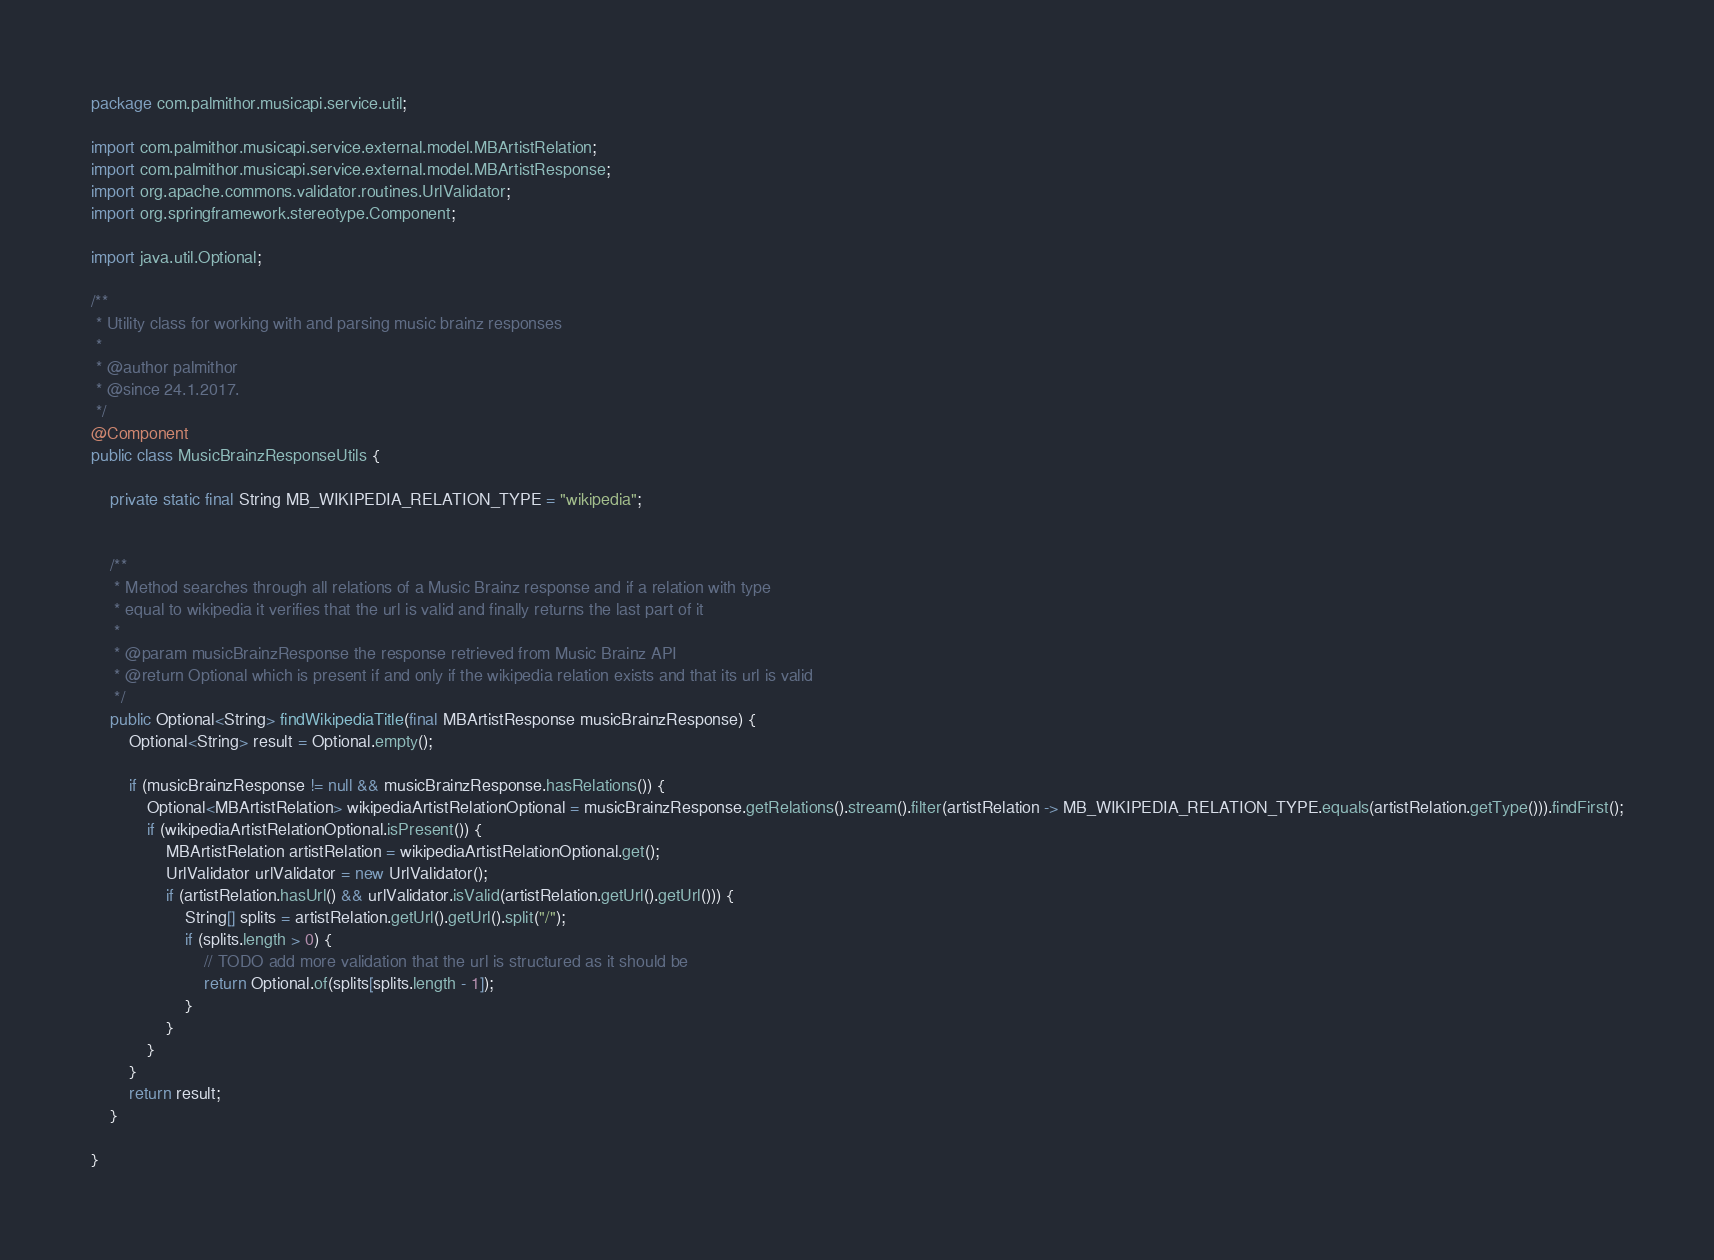<code> <loc_0><loc_0><loc_500><loc_500><_Java_>package com.palmithor.musicapi.service.util;

import com.palmithor.musicapi.service.external.model.MBArtistRelation;
import com.palmithor.musicapi.service.external.model.MBArtistResponse;
import org.apache.commons.validator.routines.UrlValidator;
import org.springframework.stereotype.Component;

import java.util.Optional;

/**
 * Utility class for working with and parsing music brainz responses
 *
 * @author palmithor
 * @since 24.1.2017.
 */
@Component
public class MusicBrainzResponseUtils {

    private static final String MB_WIKIPEDIA_RELATION_TYPE = "wikipedia";


    /**
     * Method searches through all relations of a Music Brainz response and if a relation with type
     * equal to wikipedia it verifies that the url is valid and finally returns the last part of it
     *
     * @param musicBrainzResponse the response retrieved from Music Brainz API
     * @return Optional which is present if and only if the wikipedia relation exists and that its url is valid
     */
    public Optional<String> findWikipediaTitle(final MBArtistResponse musicBrainzResponse) {
        Optional<String> result = Optional.empty();

        if (musicBrainzResponse != null && musicBrainzResponse.hasRelations()) {
            Optional<MBArtistRelation> wikipediaArtistRelationOptional = musicBrainzResponse.getRelations().stream().filter(artistRelation -> MB_WIKIPEDIA_RELATION_TYPE.equals(artistRelation.getType())).findFirst();
            if (wikipediaArtistRelationOptional.isPresent()) {
                MBArtistRelation artistRelation = wikipediaArtistRelationOptional.get();
                UrlValidator urlValidator = new UrlValidator();
                if (artistRelation.hasUrl() && urlValidator.isValid(artistRelation.getUrl().getUrl())) {
                    String[] splits = artistRelation.getUrl().getUrl().split("/");
                    if (splits.length > 0) {
                        // TODO add more validation that the url is structured as it should be
                        return Optional.of(splits[splits.length - 1]);
                    }
                }
            }
        }
        return result;
    }

}
</code> 